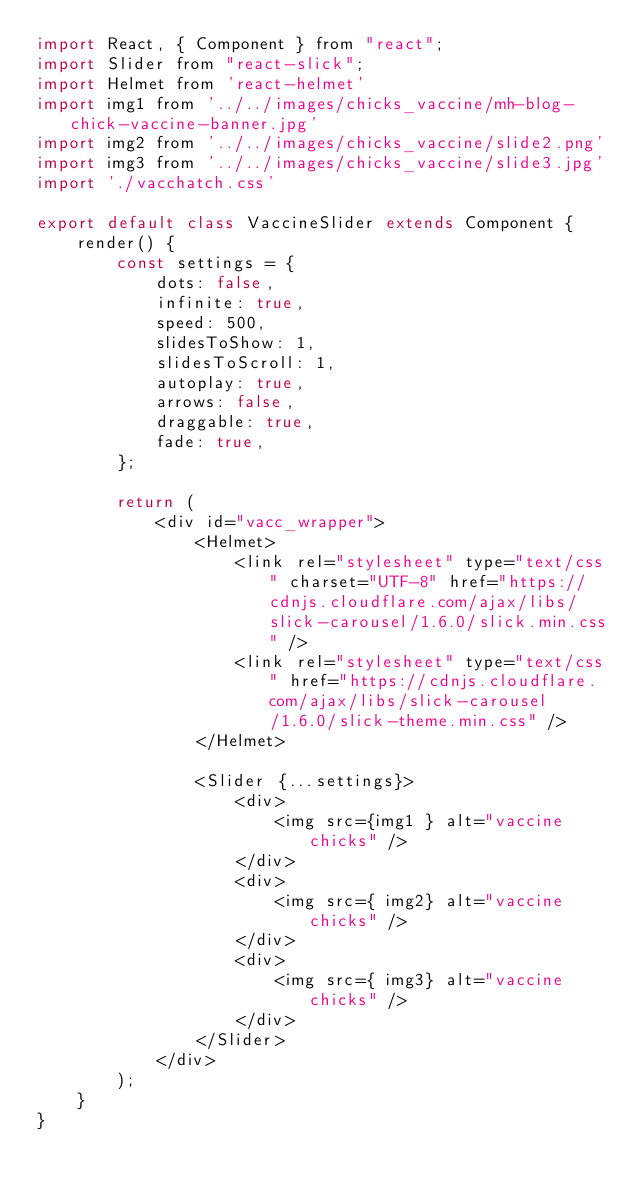Convert code to text. <code><loc_0><loc_0><loc_500><loc_500><_JavaScript_>import React, { Component } from "react";
import Slider from "react-slick";
import Helmet from 'react-helmet'
import img1 from '../../images/chicks_vaccine/mh-blog-chick-vaccine-banner.jpg'
import img2 from '../../images/chicks_vaccine/slide2.png'
import img3 from '../../images/chicks_vaccine/slide3.jpg'
import './vacchatch.css'

export default class VaccineSlider extends Component {
    render() {
        const settings = {
            dots: false,
            infinite: true,
            speed: 500,
            slidesToShow: 1,
            slidesToScroll: 1,
            autoplay: true,
            arrows: false,
            draggable: true,
            fade: true,
        };

        return (
            <div id="vacc_wrapper">
                <Helmet>
                    <link rel="stylesheet" type="text/css" charset="UTF-8" href="https://cdnjs.cloudflare.com/ajax/libs/slick-carousel/1.6.0/slick.min.css" /> 
                    <link rel="stylesheet" type="text/css" href="https://cdnjs.cloudflare.com/ajax/libs/slick-carousel/1.6.0/slick-theme.min.css" />
                </Helmet>

                <Slider {...settings}>
                    <div>
                        <img src={img1 } alt="vaccine chicks" />
                    </div>
                    <div>
                        <img src={ img2} alt="vaccine chicks" />
                    </div>
                    <div>
                        <img src={ img3} alt="vaccine chicks" />
                    </div>
                </Slider>
            </div>
        );
    }
}</code> 